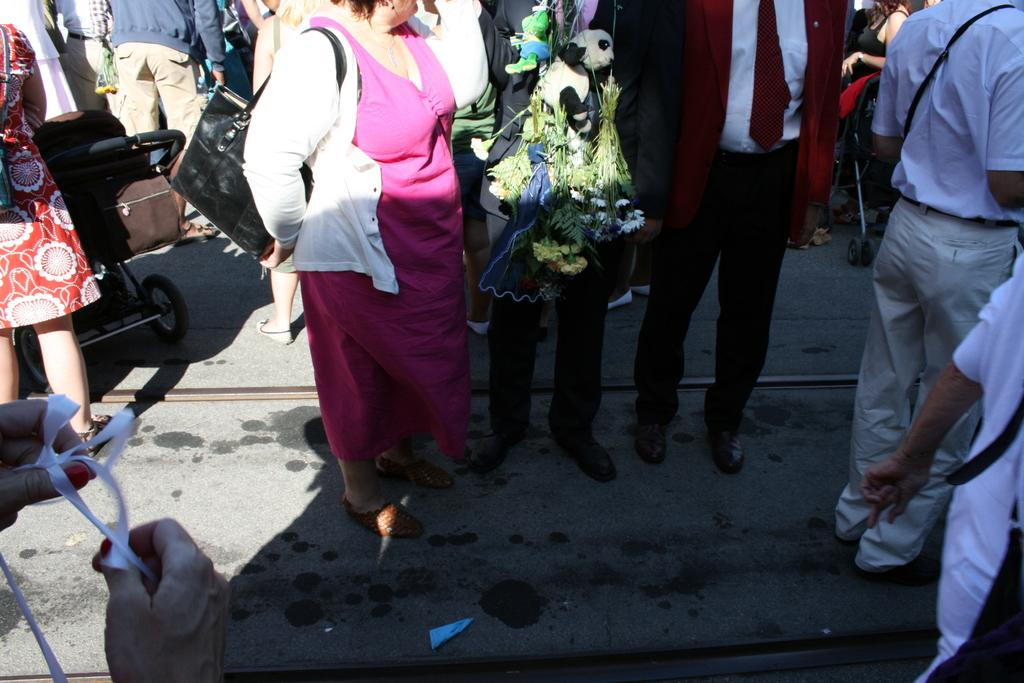What type of surface is visible in the image? There is ground visible in the image. What are the people doing on the ground? There are people standing on the ground. What objects are also present on the ground? There are two strollers on the ground. What type of soup is being served in the strollers? There is no soup present in the image; the strollers are empty. What type of rings can be seen on the people's fingers in the image? There is no mention of rings or any jewelry in the image; we only know that there are people standing on the ground and two strollers present. 